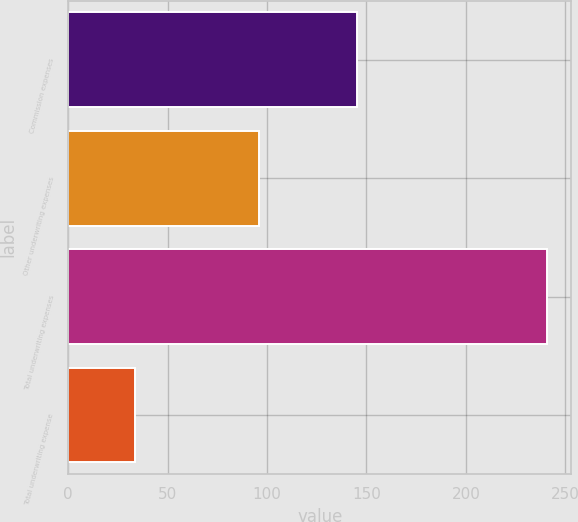Convert chart to OTSL. <chart><loc_0><loc_0><loc_500><loc_500><bar_chart><fcel>Commission expenses<fcel>Other underwriting expenses<fcel>Total underwriting expenses<fcel>Total underwriting expense<nl><fcel>145<fcel>96<fcel>241<fcel>33.4<nl></chart> 